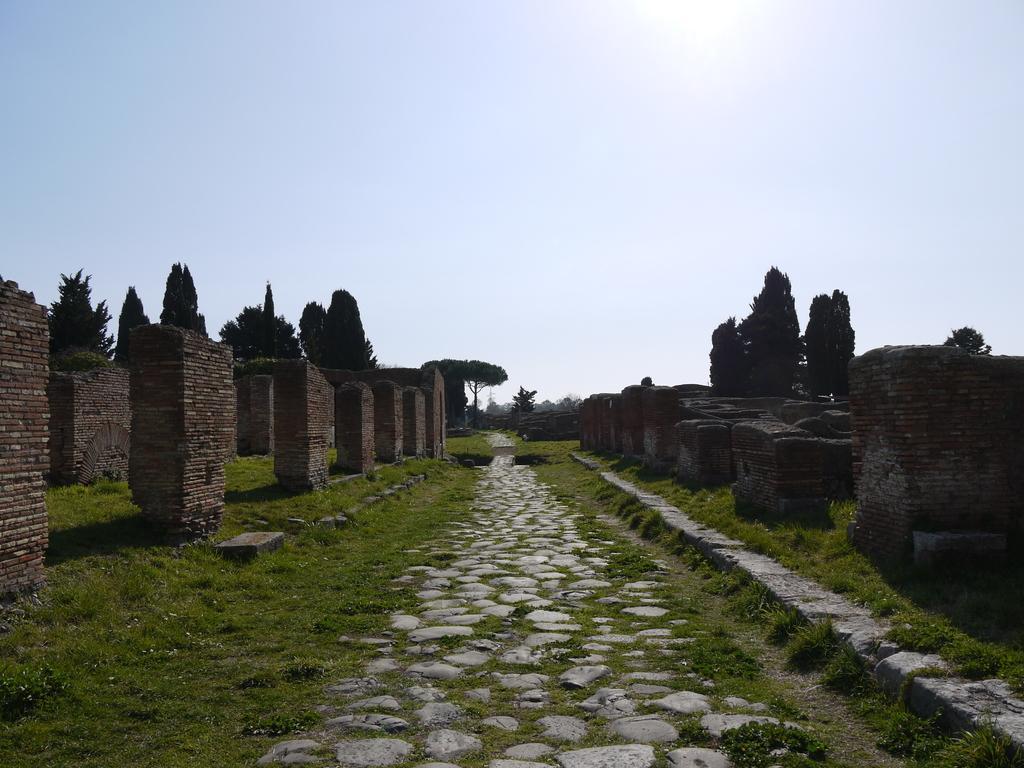Can you describe this image briefly? This image consists of walls. At the bottom, there is green grass on the ground. In the middle, there is a path. On the left right, ,there are trees. At the top, there is sky. 